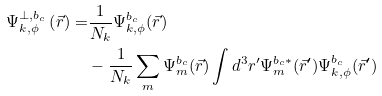<formula> <loc_0><loc_0><loc_500><loc_500>\Psi ^ { \perp , b _ { c } } _ { k , \phi } \left ( \vec { r } \right ) = & \frac { 1 } { N _ { k } } \Psi ^ { b _ { c } } _ { k , \phi } ( \vec { r } ) \\ & - \frac { 1 } { N _ { k } } \sum _ { m } \Psi ^ { b _ { c } } _ { m } ( \vec { r } ) \int d ^ { 3 } { r ^ { \prime } } \Psi ^ { b _ { c } \ast } _ { m } ( \vec { r } ^ { \prime } ) \Psi ^ { b _ { c } } _ { k , \phi } ( \vec { r } ^ { \prime } )</formula> 